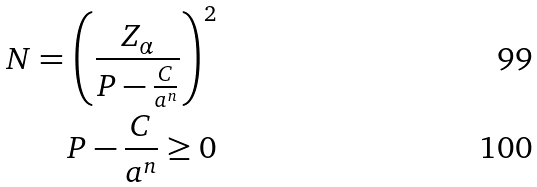<formula> <loc_0><loc_0><loc_500><loc_500>N = \left ( \frac { Z _ { \alpha } } { P - \frac { C } { a ^ { n } } } \right ) ^ { 2 } \\ P - \frac { C } { a ^ { n } } \geq 0</formula> 